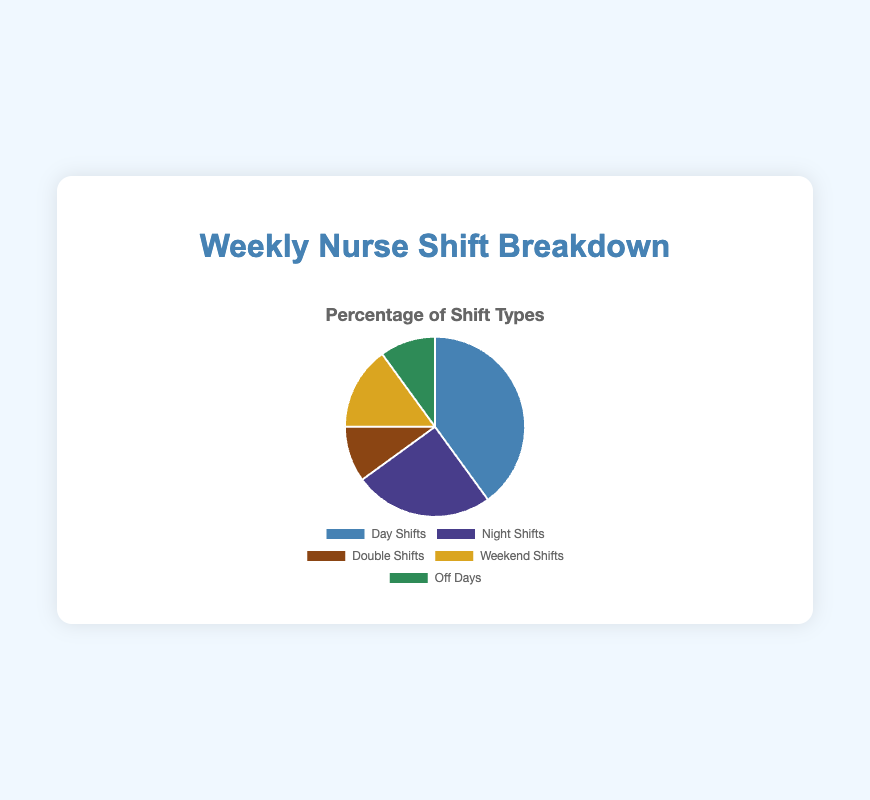What percentage of shifts worked are either Night Shifts or Double Shifts? Add the percentages of Night Shifts (25%) and Double Shifts (10%). 25% + 10% = 35%
Answer: 35% Which shift type is the most common? The largest portion of the pie chart represents Day Shifts at 40%.
Answer: Day Shifts Are Weekend Shifts more frequent than Double Shifts? Compare the percentages of Weekend Shifts (15%) and Double Shifts (10%). 15% is greater than 10%.
Answer: Yes What is the ratio of Day Shifts to Off Days? Divide the percentage of Day Shifts (40%) by the percentage of Off Days (10%). 40 / 10 = 4
Answer: 4:1 Which have the same percentage representation: Double Shifts or Off Days? Both Double Shifts and Off Days have a percentage of 10%.
Answer: Both How much more frequent are Day Shifts compared to Night Shifts? Subtract the percentage of Night Shifts (25%) from Day Shifts (40%). 40% - 25% = 15%
Answer: 15% more frequent If you combine Double Shifts and Off Days, what is their combined representation in percentage? Add the percentages of Double Shifts (10%) and Off Days (10%). 10% + 10% = 20%
Answer: 20% Which shift type has the second highest percentage? The second largest portion of the pie chart represents Night Shifts at 25%.
Answer: Night Shifts 